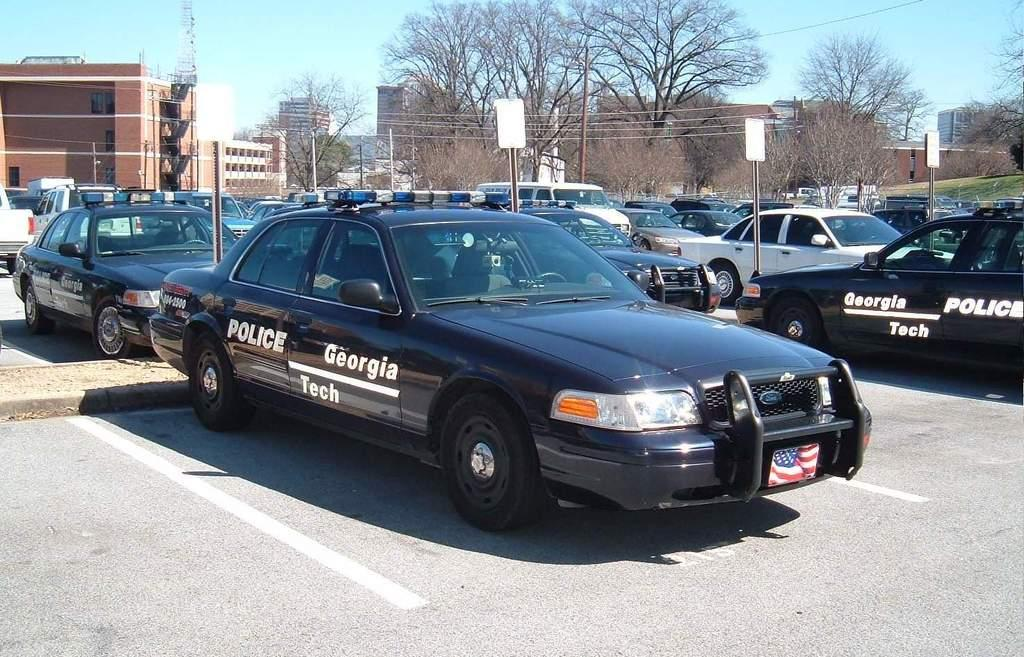What can be seen in the parking area in the image? There are many cars parked in the parking area in the image. What is written on the cars? There is writing on the cars in the image. What structures are present in the image besides the cars? There are boards with poles in the image. What can be seen in the background of the image? There are trees, buildings, and the sky visible in the background of the image. What type of plantation can be seen in the image? There is no plantation present in the image. What type of clouds can be seen in the sky in the image? The sky is visible in the background of the image, but there is no mention of clouds. 